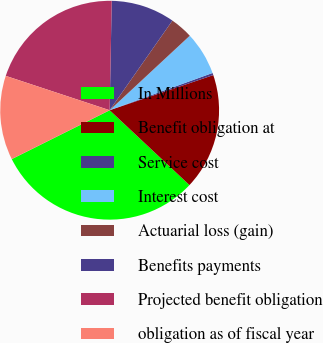Convert chart. <chart><loc_0><loc_0><loc_500><loc_500><pie_chart><fcel>In Millions<fcel>Benefit obligation at<fcel>Service cost<fcel>Interest cost<fcel>Actuarial loss (gain)<fcel>Benefits payments<fcel>Projected benefit obligation<fcel>obligation as of fiscal year<nl><fcel>30.64%<fcel>17.19%<fcel>0.33%<fcel>6.39%<fcel>3.36%<fcel>9.42%<fcel>20.22%<fcel>12.45%<nl></chart> 